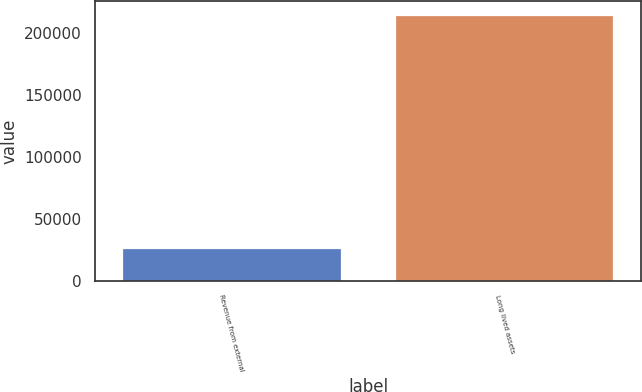Convert chart. <chart><loc_0><loc_0><loc_500><loc_500><bar_chart><fcel>Revenue from external<fcel>Long lived assets<nl><fcel>26099<fcel>215026<nl></chart> 